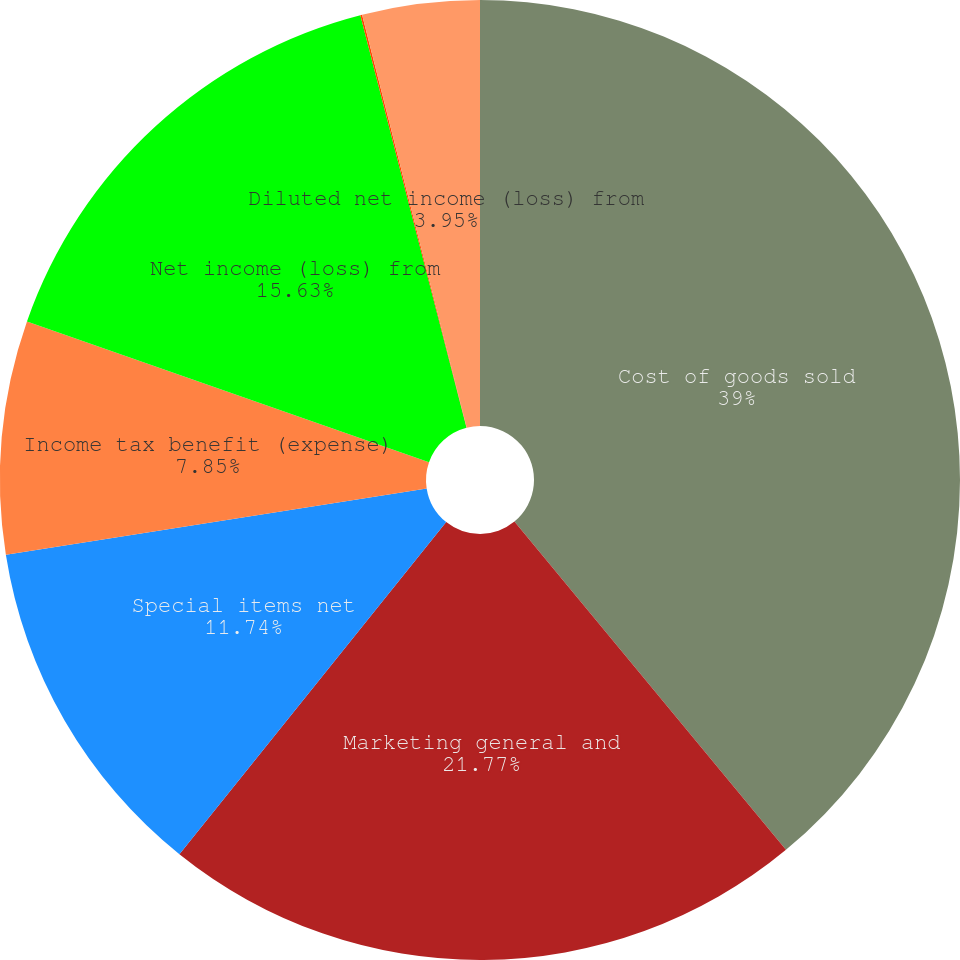Convert chart to OTSL. <chart><loc_0><loc_0><loc_500><loc_500><pie_chart><fcel>Cost of goods sold<fcel>Marketing general and<fcel>Special items net<fcel>Income tax benefit (expense)<fcel>Net income (loss) from<fcel>Basic net income (loss)<fcel>Diluted net income (loss) from<nl><fcel>39.0%<fcel>21.77%<fcel>11.74%<fcel>7.85%<fcel>15.63%<fcel>0.06%<fcel>3.95%<nl></chart> 